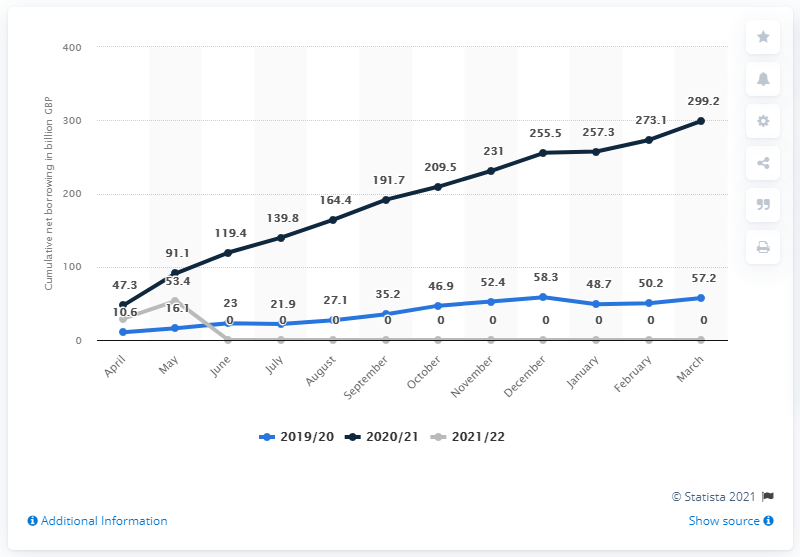Give some essential details in this illustration. The total borrowing in the United Kingdom for the 2020/21 financial year was 53.4 billion pounds. The total borrowing in March 2021 was 299.2. 